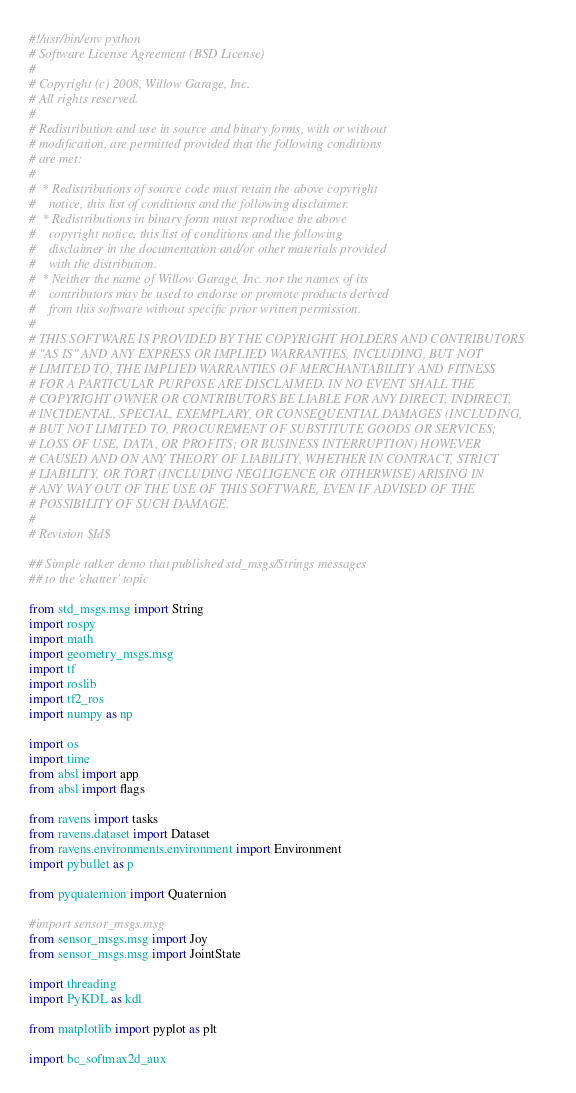Convert code to text. <code><loc_0><loc_0><loc_500><loc_500><_Python_>#!/usr/bin/env python
# Software License Agreement (BSD License)
#
# Copyright (c) 2008, Willow Garage, Inc.
# All rights reserved.
#
# Redistribution and use in source and binary forms, with or without
# modification, are permitted provided that the following conditions
# are met:
#
#  * Redistributions of source code must retain the above copyright
#    notice, this list of conditions and the following disclaimer.
#  * Redistributions in binary form must reproduce the above
#    copyright notice, this list of conditions and the following
#    disclaimer in the documentation and/or other materials provided
#    with the distribution.
#  * Neither the name of Willow Garage, Inc. nor the names of its
#    contributors may be used to endorse or promote products derived
#    from this software without specific prior written permission.
#
# THIS SOFTWARE IS PROVIDED BY THE COPYRIGHT HOLDERS AND CONTRIBUTORS
# "AS IS" AND ANY EXPRESS OR IMPLIED WARRANTIES, INCLUDING, BUT NOT
# LIMITED TO, THE IMPLIED WARRANTIES OF MERCHANTABILITY AND FITNESS
# FOR A PARTICULAR PURPOSE ARE DISCLAIMED. IN NO EVENT SHALL THE
# COPYRIGHT OWNER OR CONTRIBUTORS BE LIABLE FOR ANY DIRECT, INDIRECT,
# INCIDENTAL, SPECIAL, EXEMPLARY, OR CONSEQUENTIAL DAMAGES (INCLUDING,
# BUT NOT LIMITED TO, PROCUREMENT OF SUBSTITUTE GOODS OR SERVICES;
# LOSS OF USE, DATA, OR PROFITS; OR BUSINESS INTERRUPTION) HOWEVER
# CAUSED AND ON ANY THEORY OF LIABILITY, WHETHER IN CONTRACT, STRICT
# LIABILITY, OR TORT (INCLUDING NEGLIGENCE OR OTHERWISE) ARISING IN
# ANY WAY OUT OF THE USE OF THIS SOFTWARE, EVEN IF ADVISED OF THE
# POSSIBILITY OF SUCH DAMAGE.
#
# Revision $Id$

## Simple talker demo that published std_msgs/Strings messages
## to the 'chatter' topic

from std_msgs.msg import String
import rospy
import math
import geometry_msgs.msg
import tf
import roslib
import tf2_ros
import numpy as np

import os
import time
from absl import app
from absl import flags

from ravens import tasks
from ravens.dataset import Dataset
from ravens.environments.environment import Environment
import pybullet as p

from pyquaternion import Quaternion

#import sensor_msgs.msg
from sensor_msgs.msg import Joy
from sensor_msgs.msg import JointState

import threading 
import PyKDL as kdl

from matplotlib import pyplot as plt

import bc_softmax2d_aux</code> 